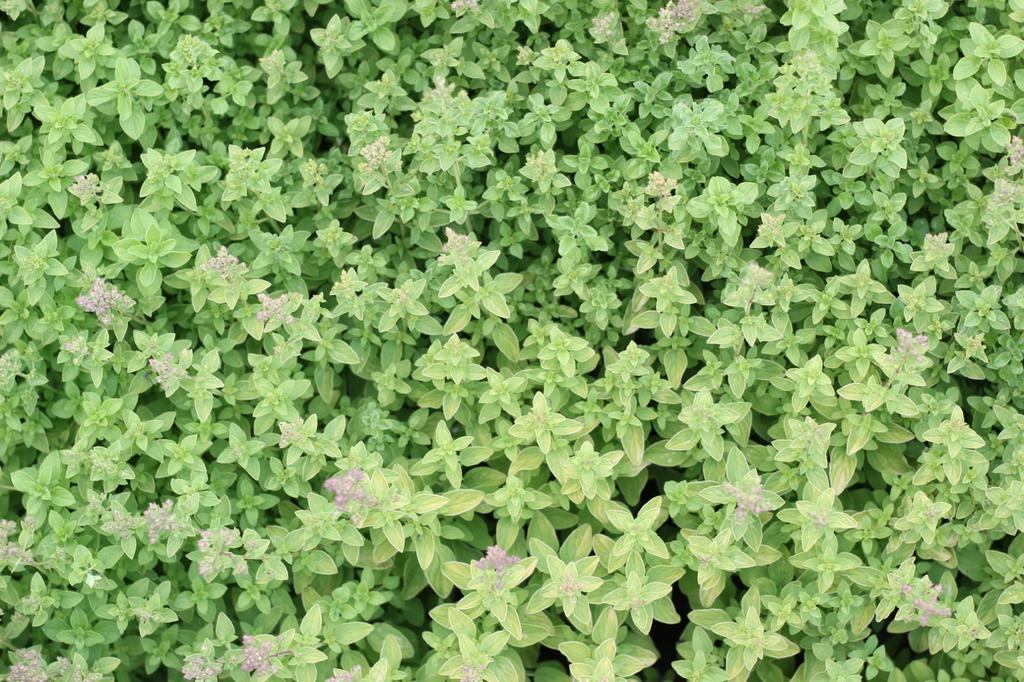Can you describe this image briefly? There are plants having green color leaves. Some of these plants are having flowers. 